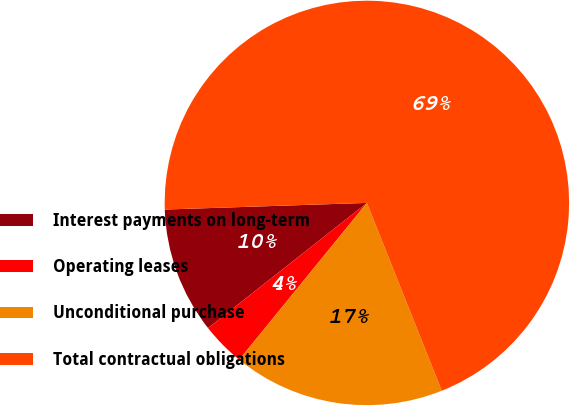<chart> <loc_0><loc_0><loc_500><loc_500><pie_chart><fcel>Interest payments on long-term<fcel>Operating leases<fcel>Unconditional purchase<fcel>Total contractual obligations<nl><fcel>10.1%<fcel>3.5%<fcel>16.92%<fcel>69.48%<nl></chart> 